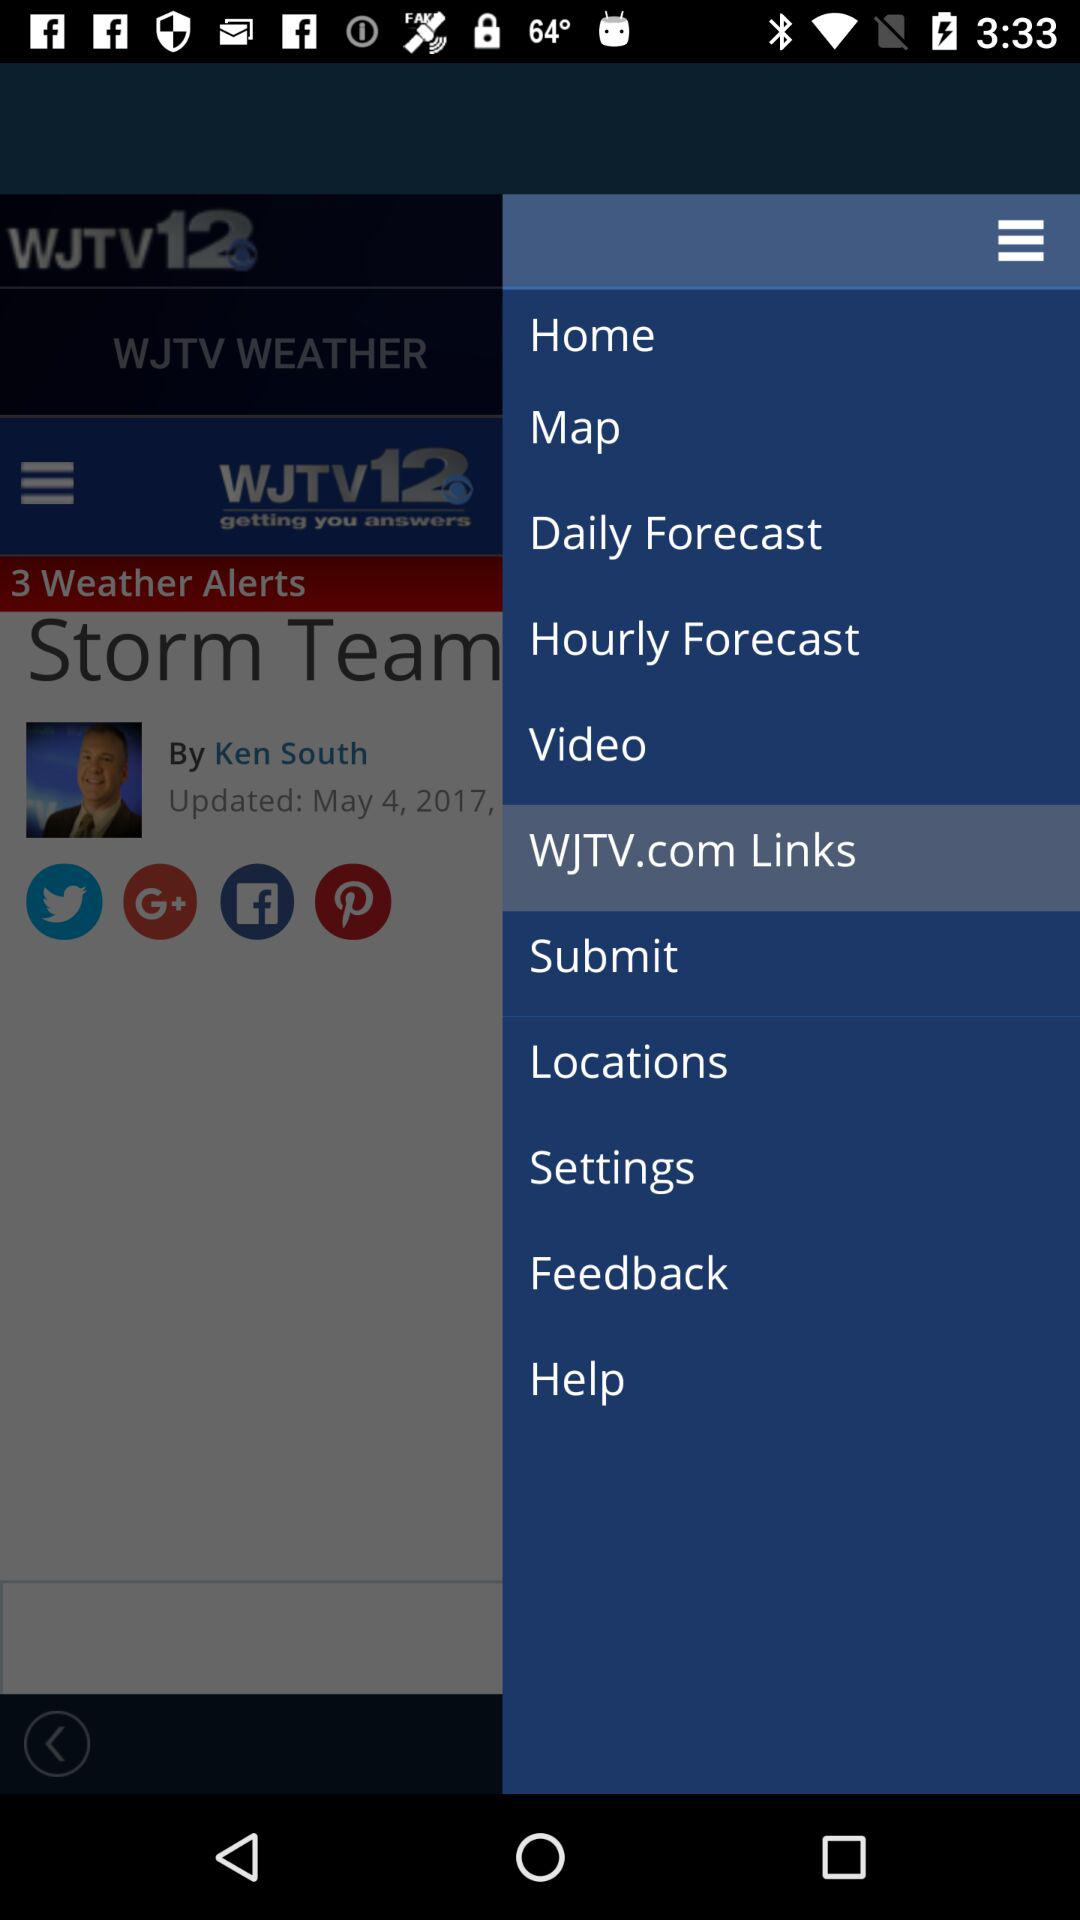Which option is selected? The selected option is "WJTV.com Links". 